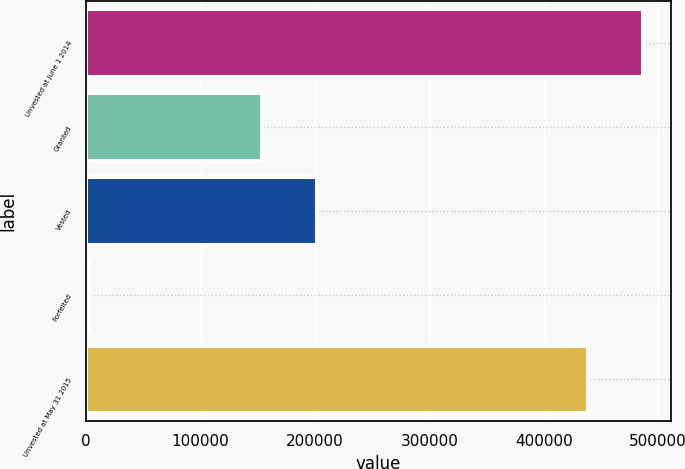Convert chart. <chart><loc_0><loc_0><loc_500><loc_500><bar_chart><fcel>Unvested at June 1 2014<fcel>Granted<fcel>Vested<fcel>Forfeited<fcel>Unvested at May 31 2015<nl><fcel>486827<fcel>154115<fcel>201900<fcel>2310<fcel>439042<nl></chart> 